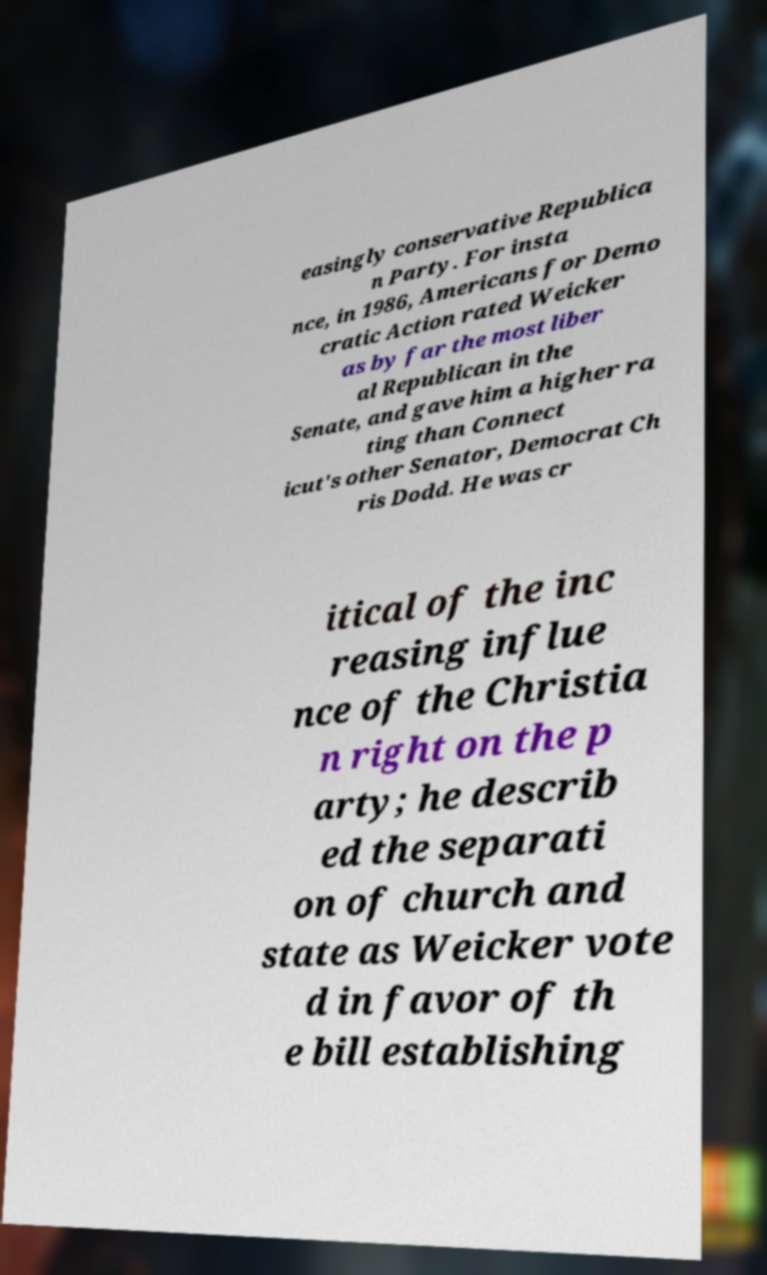Could you extract and type out the text from this image? easingly conservative Republica n Party. For insta nce, in 1986, Americans for Demo cratic Action rated Weicker as by far the most liber al Republican in the Senate, and gave him a higher ra ting than Connect icut's other Senator, Democrat Ch ris Dodd. He was cr itical of the inc reasing influe nce of the Christia n right on the p arty; he describ ed the separati on of church and state as Weicker vote d in favor of th e bill establishing 